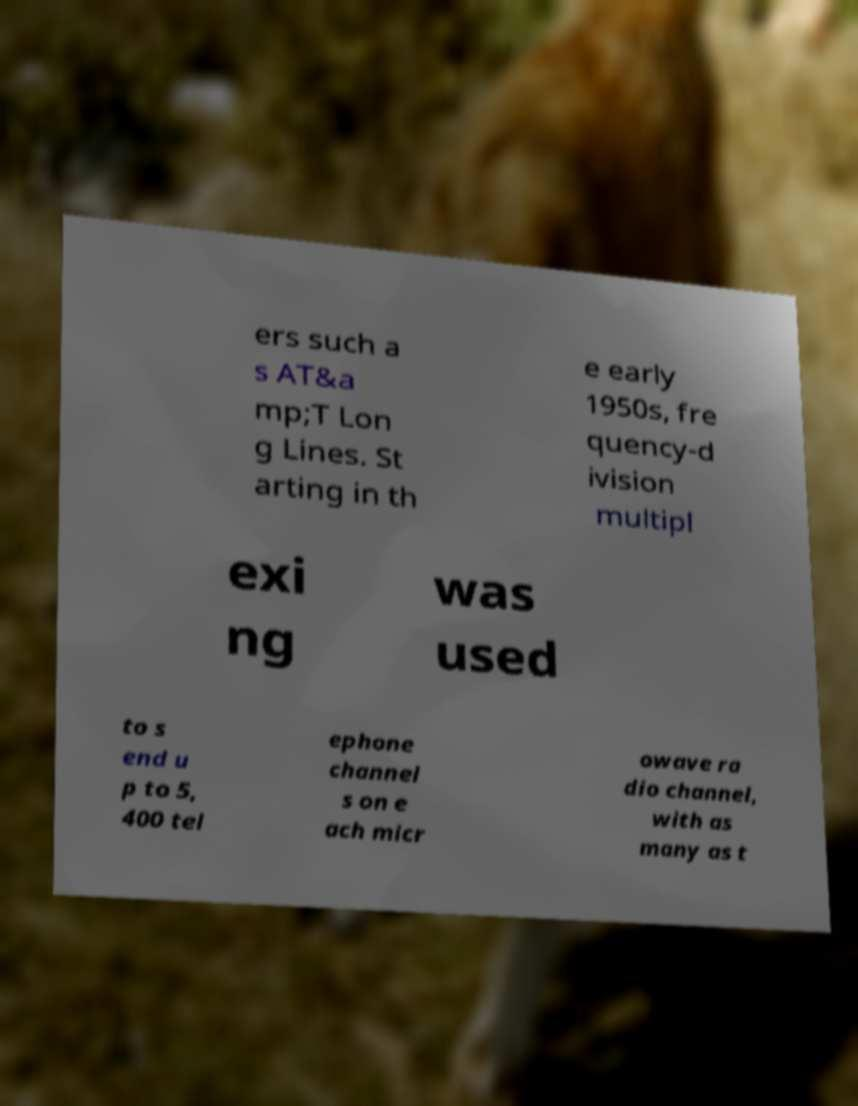Could you extract and type out the text from this image? ers such a s AT&a mp;T Lon g Lines. St arting in th e early 1950s, fre quency-d ivision multipl exi ng was used to s end u p to 5, 400 tel ephone channel s on e ach micr owave ra dio channel, with as many as t 